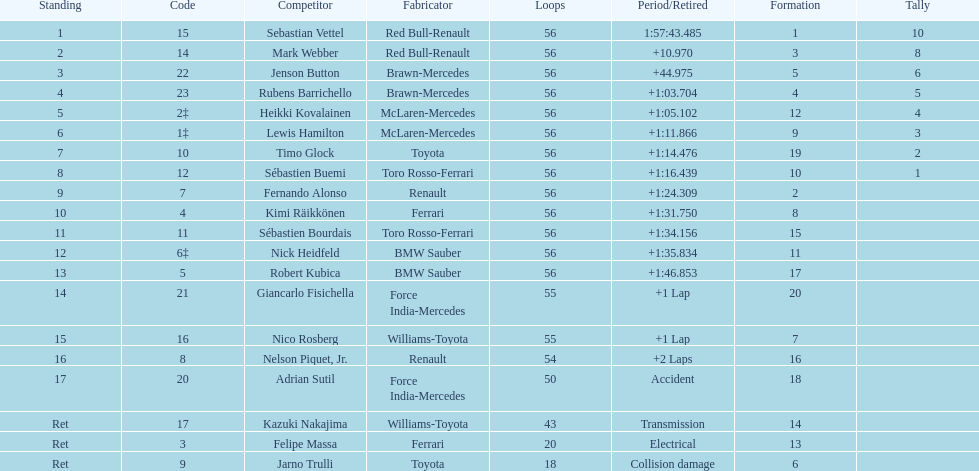Would you be able to parse every entry in this table? {'header': ['Standing', 'Code', 'Competitor', 'Fabricator', 'Loops', 'Period/Retired', 'Formation', 'Tally'], 'rows': [['1', '15', 'Sebastian Vettel', 'Red Bull-Renault', '56', '1:57:43.485', '1', '10'], ['2', '14', 'Mark Webber', 'Red Bull-Renault', '56', '+10.970', '3', '8'], ['3', '22', 'Jenson Button', 'Brawn-Mercedes', '56', '+44.975', '5', '6'], ['4', '23', 'Rubens Barrichello', 'Brawn-Mercedes', '56', '+1:03.704', '4', '5'], ['5', '2‡', 'Heikki Kovalainen', 'McLaren-Mercedes', '56', '+1:05.102', '12', '4'], ['6', '1‡', 'Lewis Hamilton', 'McLaren-Mercedes', '56', '+1:11.866', '9', '3'], ['7', '10', 'Timo Glock', 'Toyota', '56', '+1:14.476', '19', '2'], ['8', '12', 'Sébastien Buemi', 'Toro Rosso-Ferrari', '56', '+1:16.439', '10', '1'], ['9', '7', 'Fernando Alonso', 'Renault', '56', '+1:24.309', '2', ''], ['10', '4', 'Kimi Räikkönen', 'Ferrari', '56', '+1:31.750', '8', ''], ['11', '11', 'Sébastien Bourdais', 'Toro Rosso-Ferrari', '56', '+1:34.156', '15', ''], ['12', '6‡', 'Nick Heidfeld', 'BMW Sauber', '56', '+1:35.834', '11', ''], ['13', '5', 'Robert Kubica', 'BMW Sauber', '56', '+1:46.853', '17', ''], ['14', '21', 'Giancarlo Fisichella', 'Force India-Mercedes', '55', '+1 Lap', '20', ''], ['15', '16', 'Nico Rosberg', 'Williams-Toyota', '55', '+1 Lap', '7', ''], ['16', '8', 'Nelson Piquet, Jr.', 'Renault', '54', '+2 Laps', '16', ''], ['17', '20', 'Adrian Sutil', 'Force India-Mercedes', '50', 'Accident', '18', ''], ['Ret', '17', 'Kazuki Nakajima', 'Williams-Toyota', '43', 'Transmission', '14', ''], ['Ret', '3', 'Felipe Massa', 'Ferrari', '20', 'Electrical', '13', ''], ['Ret', '9', 'Jarno Trulli', 'Toyota', '18', 'Collision damage', '6', '']]} What was jenson button's time? +44.975. 